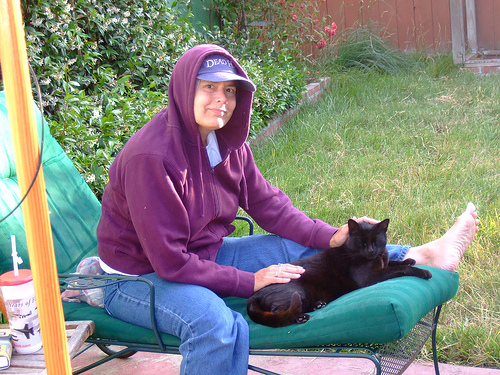<image>
Can you confirm if the cat is on the grass? No. The cat is not positioned on the grass. They may be near each other, but the cat is not supported by or resting on top of the grass. Is the woman behind the cat? Yes. From this viewpoint, the woman is positioned behind the cat, with the cat partially or fully occluding the woman. Where is the head in relation to the cat? Is it behind the cat? No. The head is not behind the cat. From this viewpoint, the head appears to be positioned elsewhere in the scene. Is there a cat in front of the woman? Yes. The cat is positioned in front of the woman, appearing closer to the camera viewpoint. 